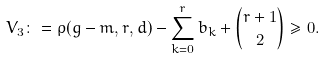Convert formula to latex. <formula><loc_0><loc_0><loc_500><loc_500>V _ { 3 } \colon = \rho ( g - m , r , d ) - \sum _ { k = 0 } ^ { r } b _ { k } + { r + 1 \choose 2 } \geq 0 .</formula> 